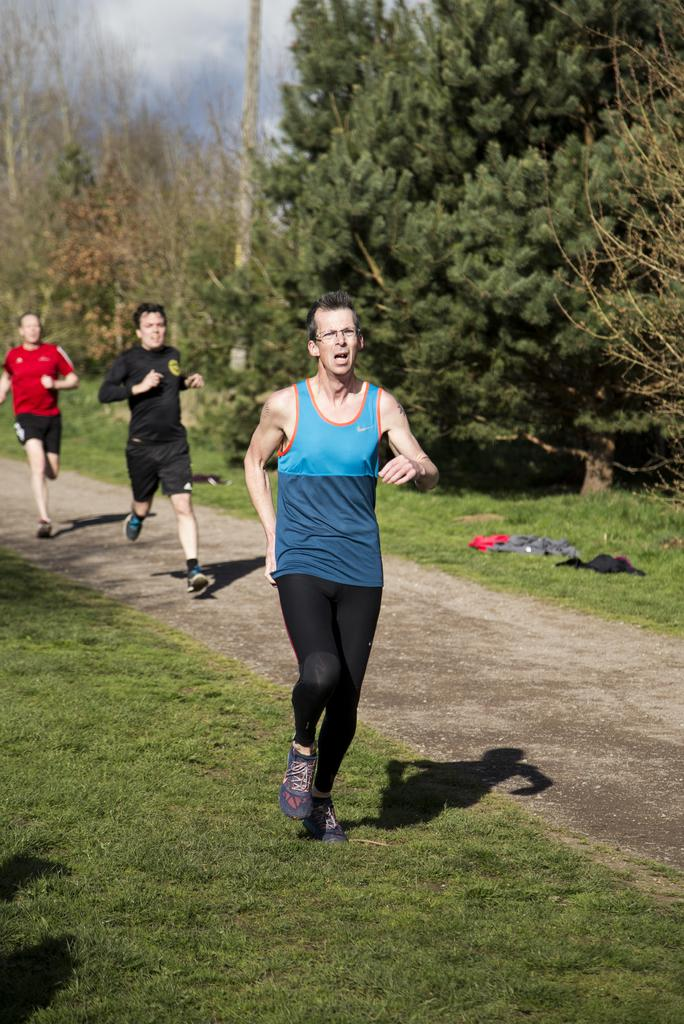What are the men in the image doing? The men in the image are running. What type of vegetation is present in the image? There are trees and grass in the image. What is on the ground in the image? There are clothes on the ground in the image. What is the condition of the sky in the image? The sky is cloudy in the image. What type of stove can be seen in the image? There is no stove present in the image. What song are the men singing while running in the image? There is no indication in the image that the men are singing, so it cannot be determined from the picture. 